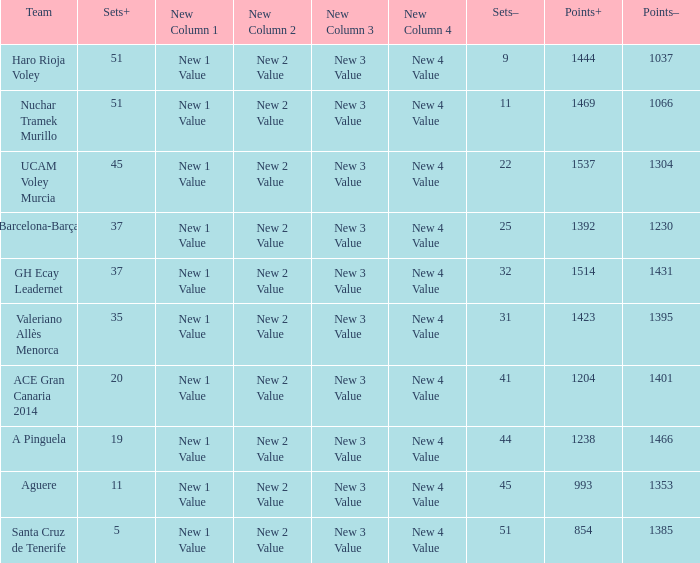What is the highest Points+ number that has a Sets+ number larger than 45, a Sets- number larger than 9, and a Points- number smaller than 1066? None. 